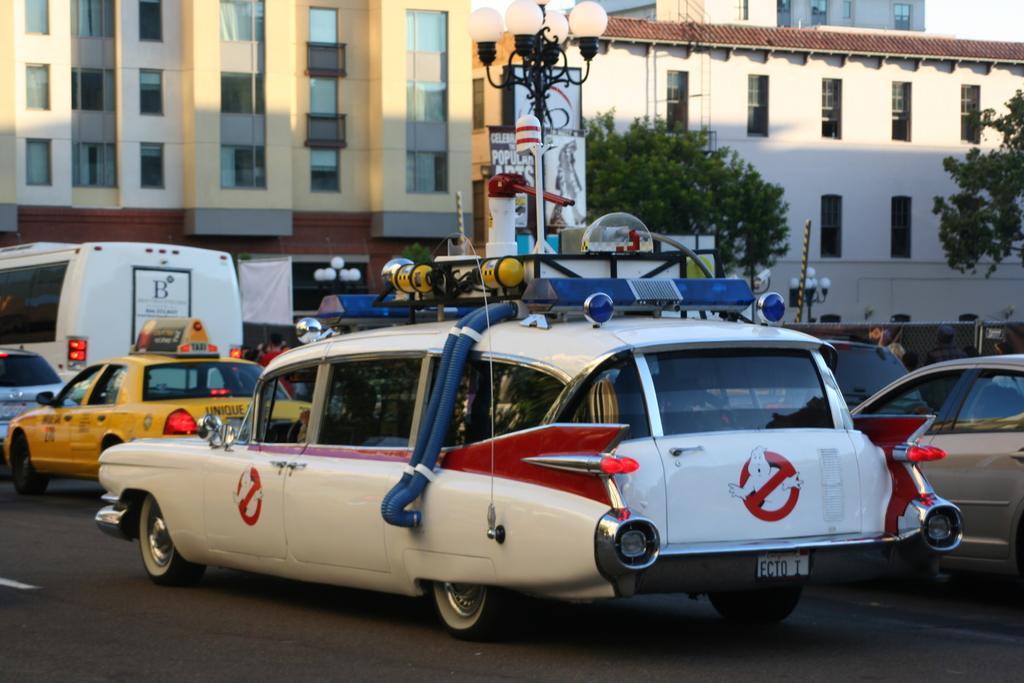How would you summarize this image in a sentence or two? In this picture, we see vehicles parked on the road. At the bottom of the picture, we see the road. There are street lights, trees and buildings in the background. 